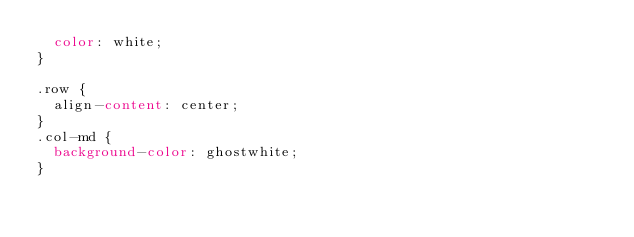<code> <loc_0><loc_0><loc_500><loc_500><_CSS_>  color: white;
}

.row {
  align-content: center;
}
.col-md {
  background-color: ghostwhite;
}
</code> 